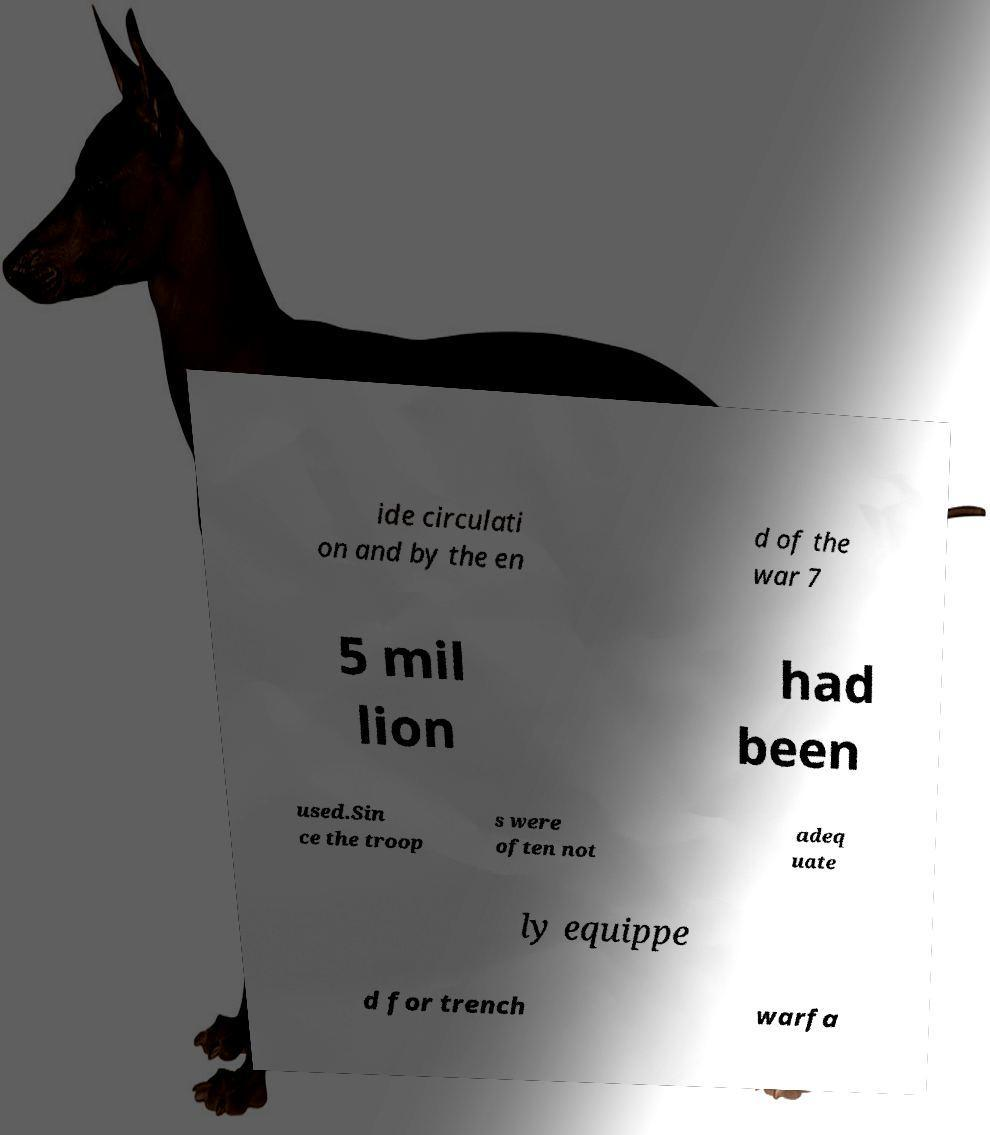I need the written content from this picture converted into text. Can you do that? ide circulati on and by the en d of the war 7 5 mil lion had been used.Sin ce the troop s were often not adeq uate ly equippe d for trench warfa 